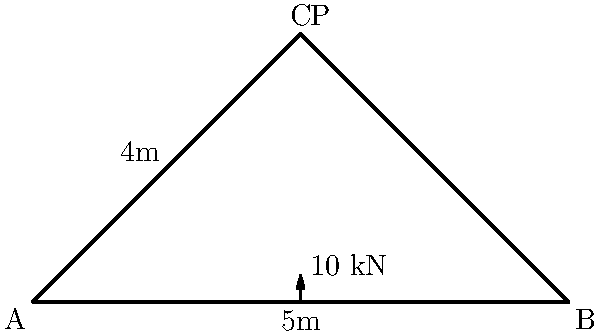A simple truss bridge is designed as shown in the diagram. The bridge span is 10 meters, and the height at the center is 4 meters. A point load P of 10 kN is applied at the apex. Assuming the structure is symmetrical and ignoring the self-weight, calculate the maximum axial force in any member of the truss. How does this relate to the bridge's loading time, considering the importance of fast-loading pages for online shoppers? Let's solve this step-by-step:

1) First, we need to find the reactions at the supports. Due to symmetry, each support will bear half of the applied load:

   $R_A = R_B = 5 \text{ kN}$

2) Now, we can analyze the forces in the members. The most stressed member will be either AC or BC due to symmetry.

3) To find the force in AC (or BC), we can use the method of joints at point C:

4) Vertical force equilibrium at C:
   $F_{AC} \sin \theta + F_{BC} \sin \theta = 10 \text{ kN}$
   Due to symmetry, $F_{AC} = F_{BC}$, so:
   $2F_{AC} \sin \theta = 10 \text{ kN}$

5) We need to find $\sin \theta$:
   $\sin \theta = \frac{4}{5} = 0.8$ (using the right triangle formed by half the bridge)

6) Substituting this in our equation:
   $2F_{AC} (0.8) = 10 \text{ kN}$
   $F_{AC} = \frac{10}{1.6} = 6.25 \text{ kN}$

7) Therefore, the maximum axial force in any member is 6.25 kN (compression in AC and BC).

Relating to fast-loading pages: The efficient design of the truss distributes the load evenly, minimizing the maximum force in any member. Similarly, well-designed websites distribute data load efficiently, ensuring faster page loading times. Just as a well-designed bridge can handle higher loads more efficiently, a well-optimized website can handle more data while maintaining fast loading speeds, which is crucial for online shoppers and fashion bloggers browsing through image-heavy online stores.
Answer: 6.25 kN 